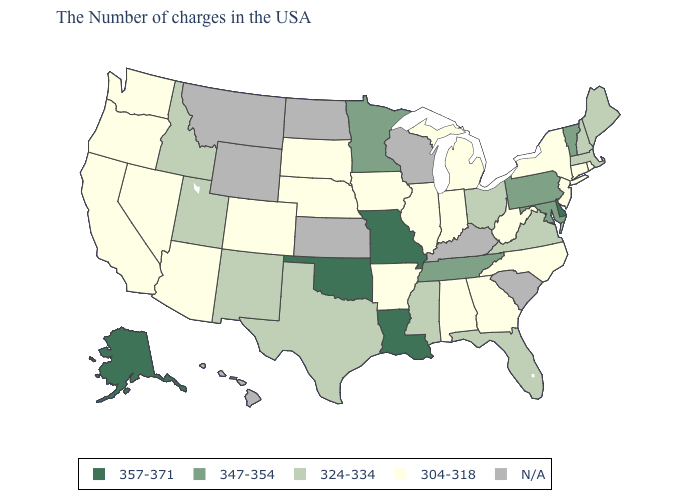What is the value of Ohio?
Write a very short answer. 324-334. What is the value of Missouri?
Keep it brief. 357-371. Which states have the highest value in the USA?
Keep it brief. Delaware, Louisiana, Missouri, Oklahoma, Alaska. What is the value of South Dakota?
Short answer required. 304-318. What is the lowest value in the South?
Give a very brief answer. 304-318. Name the states that have a value in the range 324-334?
Write a very short answer. Maine, Massachusetts, New Hampshire, Virginia, Ohio, Florida, Mississippi, Texas, New Mexico, Utah, Idaho. What is the highest value in states that border Nevada?
Write a very short answer. 324-334. Is the legend a continuous bar?
Give a very brief answer. No. Does Washington have the lowest value in the USA?
Keep it brief. Yes. Name the states that have a value in the range 304-318?
Quick response, please. Rhode Island, Connecticut, New York, New Jersey, North Carolina, West Virginia, Georgia, Michigan, Indiana, Alabama, Illinois, Arkansas, Iowa, Nebraska, South Dakota, Colorado, Arizona, Nevada, California, Washington, Oregon. Name the states that have a value in the range 304-318?
Short answer required. Rhode Island, Connecticut, New York, New Jersey, North Carolina, West Virginia, Georgia, Michigan, Indiana, Alabama, Illinois, Arkansas, Iowa, Nebraska, South Dakota, Colorado, Arizona, Nevada, California, Washington, Oregon. Which states have the lowest value in the South?
Write a very short answer. North Carolina, West Virginia, Georgia, Alabama, Arkansas. Name the states that have a value in the range 347-354?
Short answer required. Vermont, Maryland, Pennsylvania, Tennessee, Minnesota. Does California have the lowest value in the USA?
Short answer required. Yes. 